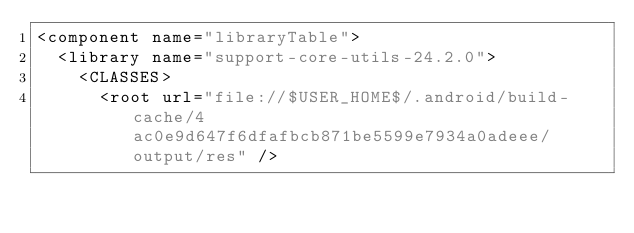Convert code to text. <code><loc_0><loc_0><loc_500><loc_500><_XML_><component name="libraryTable">
  <library name="support-core-utils-24.2.0">
    <CLASSES>
      <root url="file://$USER_HOME$/.android/build-cache/4ac0e9d647f6dfafbcb871be5599e7934a0adeee/output/res" /></code> 